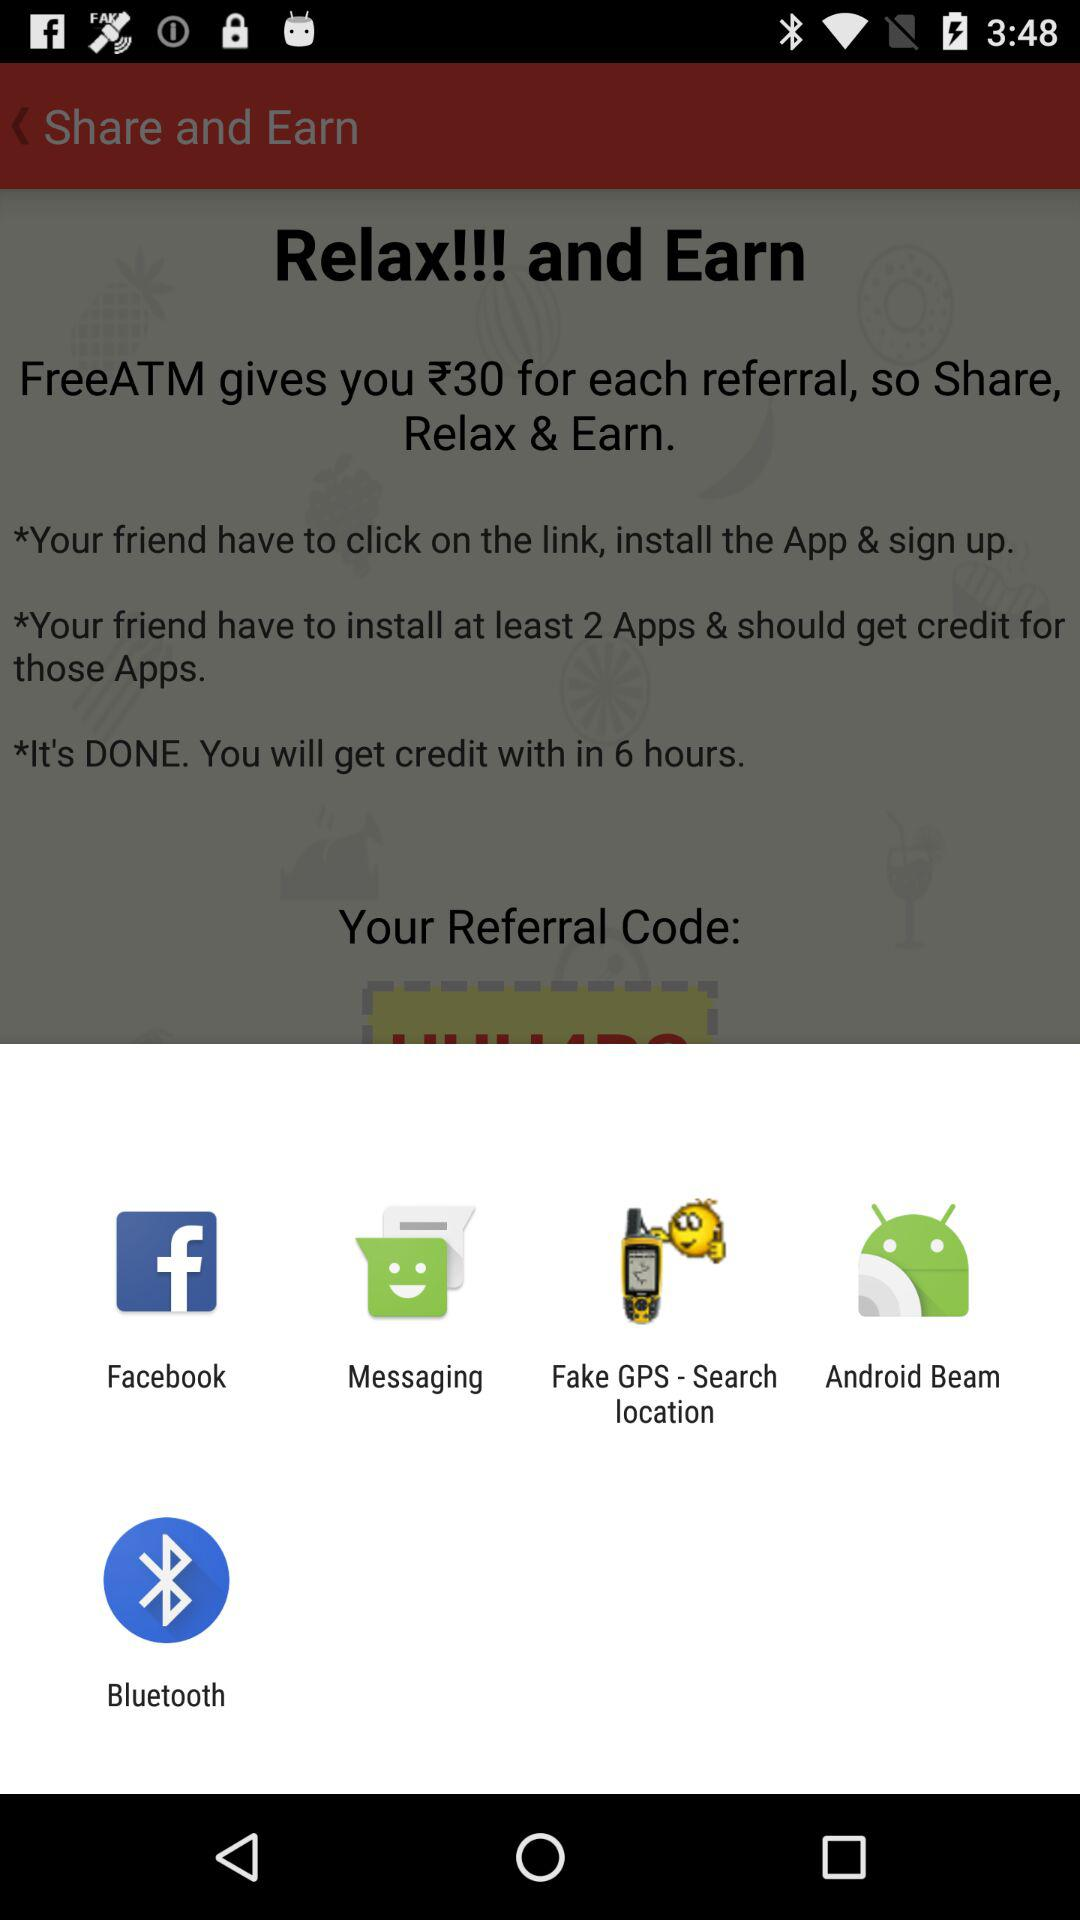Through what applications can we share? You can share it through "Facebook", "Messaging", "Fake GPS - Search location", and "Bluetooth". 